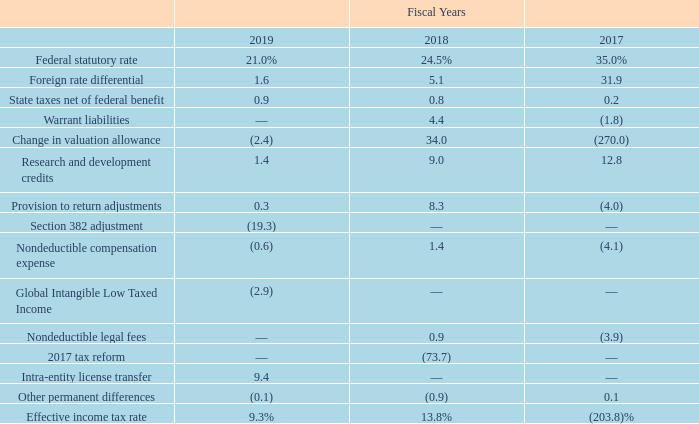The $252.5 million of valuation allowance as of September 27, 2019 relates primarily to federal and state NOLs, tax credit carryforwards and a partial valuation allowance on tax credits in Canada of $19.0 million whose recovery is not considered more likely than not. The$243.1 million of valuation allowance as of September 28, 2018 related primarily to federal and state NOLs, tax credit carryforwards and a partial valuation allowance on tax credits in Canada of$13.6 million whose recovery is not considered more likely than not. The change during the fiscal year endedSeptember 27, 2019 of $9.4 million primarily relates to the reduction of our NOLs due to section 382 limitations, the changes in our temporary differences, and the lower U.S federal tax rate.
Our effective tax rates differ from the federal and statutory rate as follows:
For fiscal years 2019, 2018 and 2017, the effective tax rates on $423.2 million, $155.2 million and $49.5 million, respectively, of pre-tax loss from continuing operations were 9.3%, 13.8% and (203.8)%, respectively.
For fiscal year 2019, the effective tax rate was primarily impacted by a change in our NOL carryforward due to an adjustment in our Section 382 limitation from a prior period acquisition and the immediate recognition of the current and deferred income tax effects totaling $39.8 million from an intra-entity transfer of a license for intellectual property to a higher taxed jurisdiction that received a tax basis step-up.
For fiscal year 2018, the effective tax rate was primarily impacted by the Tax Cuts and Jobs Act (the "Tax Act"). The effective income tax rates for fiscal years 2019, 2018 and 2017 were also impacted by a lower income tax rate in many foreign jurisdictions in which our foreign subsidiaries operate, changes in valuation allowance, research and development tax credits, and a fair market value adjustment of warrant liabilities.
All earnings of foreign subsidiaries, other than our M/A-COM Technology Solutions International Limited Cayman Islands subsidiary ("Cayman Islands subsidiary"), are considered indefinitely reinvested for the periods presented. During fiscal year 2019 we changed our position for our Cayman Islands subsidiary to no longer have its earnings permanently reinvested.
Although a foreign subsidiary would typically have to accrue for foreign withholding tax liabilities associated with undistributed earnings, Cayman Islands has no withholding tax under domestic law, therefore, we did not accrue for foreign withholding tax.
During fiscal year 2019 we finalized our calculation of the one-time deemed repatriation of gross foreign earnings and profits, totaling $156.8 million, which resulted in approximately $86.7 million in U.S. taxable income for the year ended September 28, 2018 with Grand Cayman and Ireland accounting for$ 59.7 million and $25.6 million, respectively. Due to the fact that we are in a full U.S. valuation allowance, this one-time deemed repatriation had no impact on our tax expense for fiscal year 2018.
Our fiscal year 2019 tax provision incorporated changes required by the Tax Act. Some of these changes include a new limitation on the deductible interest expense, inclusion of Global Intangible Low Taxed Income earned by controlled foreign corporations, computation of the new base erosion anti-abuse minimum tax, repealing the performance-based compensation exception to section 162(m) and revising the definition of a covered employee.
What was the respective effective income tax rate in 2019, 2018 and 2017? 9.3%, 13.8%, (203.8)%. What was the respective foreign rate differential in 2019, 2018 and 2017?
Answer scale should be: percent. 1.6, 5.1, 31.9. What was the Federal statutory rate in 2019?
Answer scale should be: percent. 21.0. In which year was Foreign rate differential greater than 10.0? Locate and analyze foreign rate differential in row 4
answer: 2017. What was the average State taxes net of federal benefit for 2017-2019?
Answer scale should be: percent. (0.9 + 0.8 + 0.2) / 3
Answer: 0.63. What is the change in the Research and development credits from 2018 to 2019?
Answer scale should be: percent. 1.4 - 9.0
Answer: -7.6. 